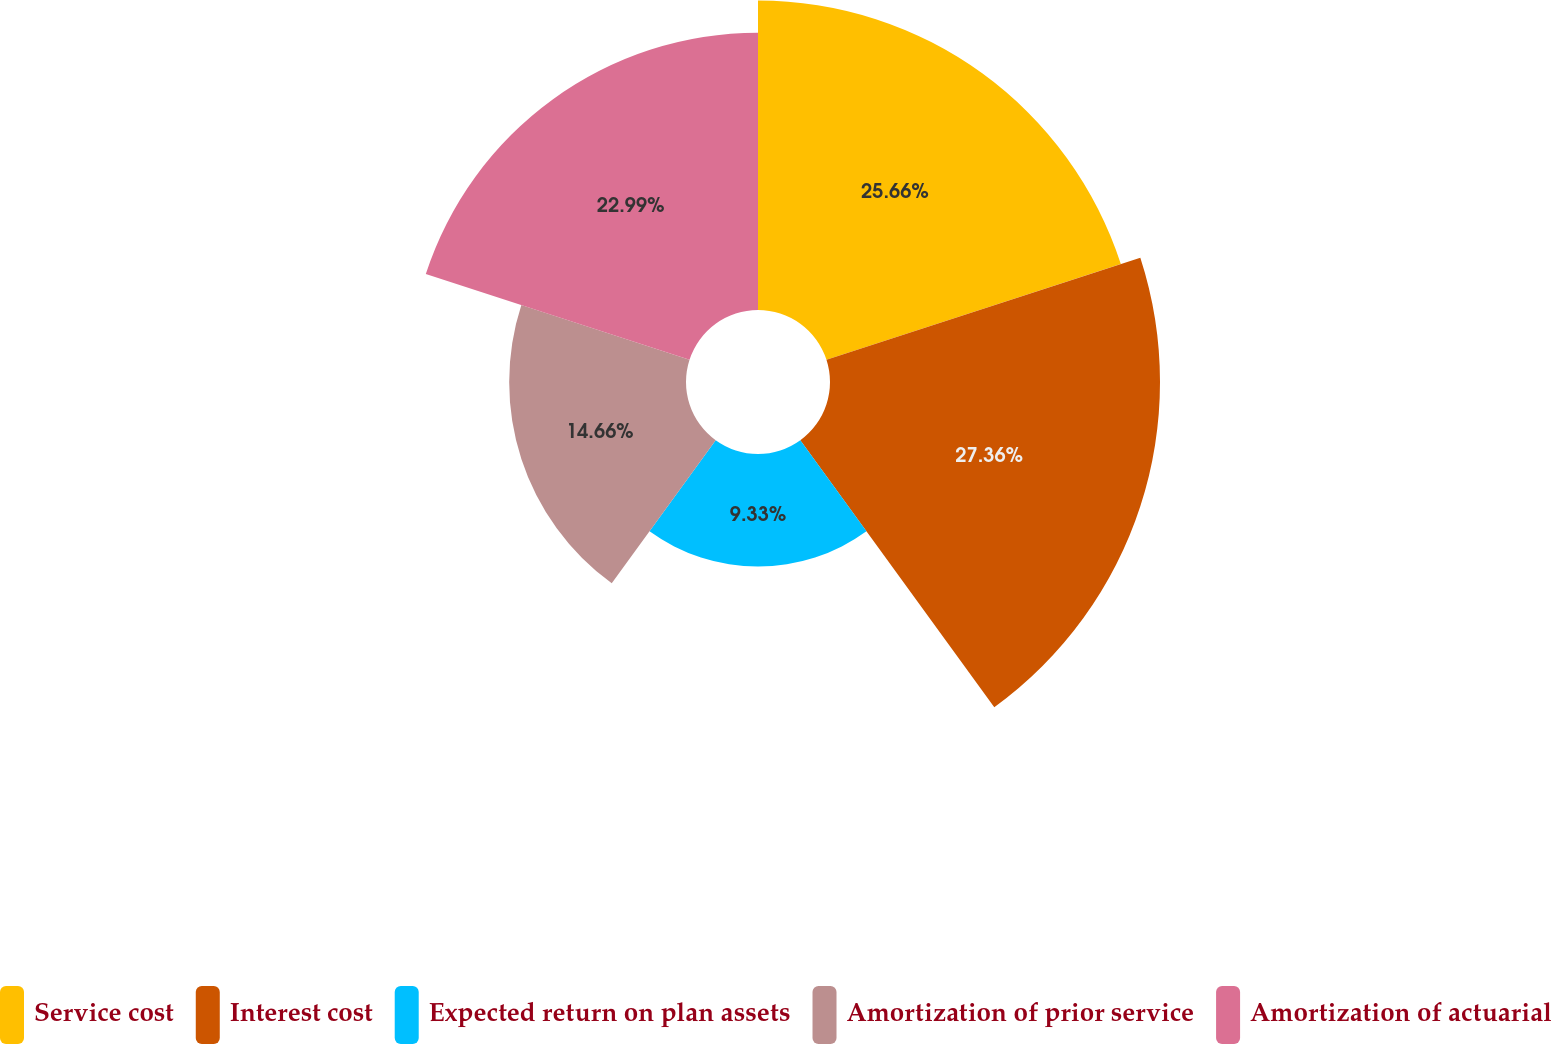Convert chart. <chart><loc_0><loc_0><loc_500><loc_500><pie_chart><fcel>Service cost<fcel>Interest cost<fcel>Expected return on plan assets<fcel>Amortization of prior service<fcel>Amortization of actuarial<nl><fcel>25.66%<fcel>27.36%<fcel>9.33%<fcel>14.66%<fcel>22.99%<nl></chart> 